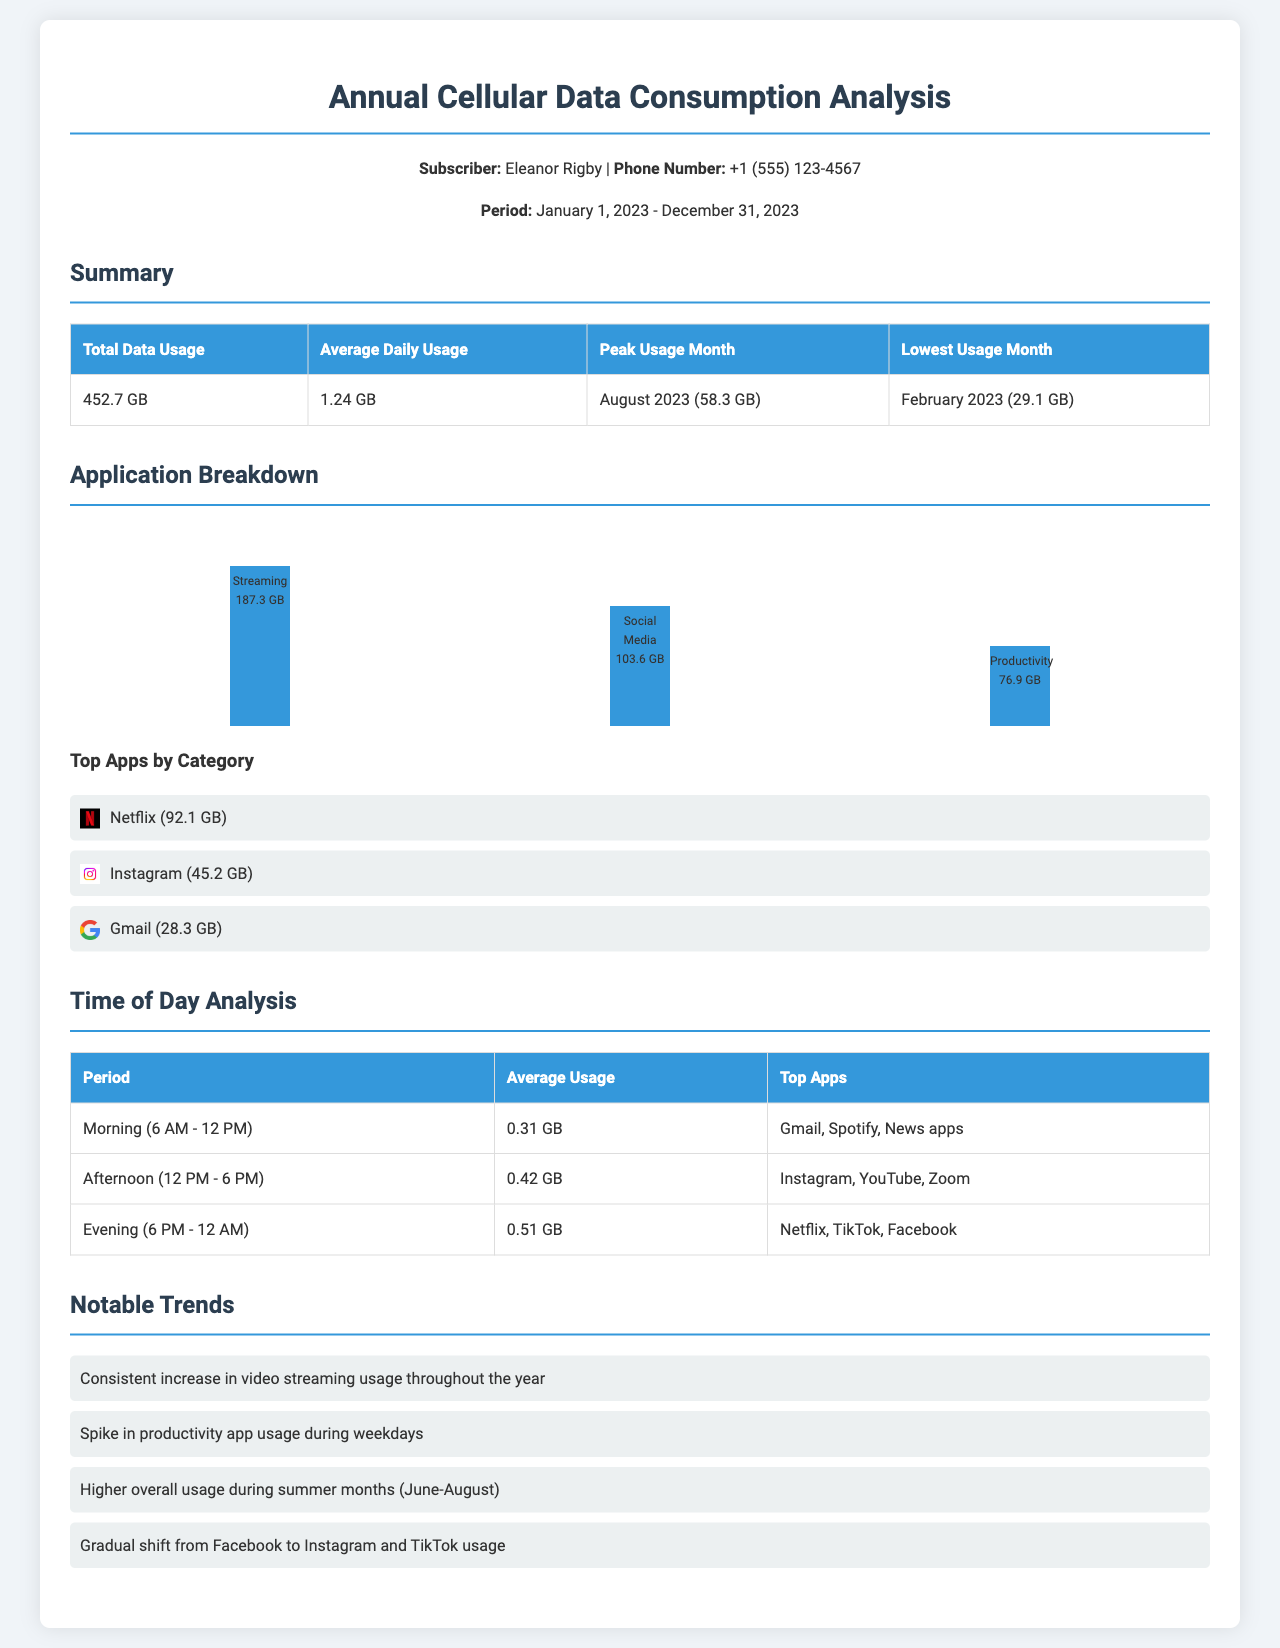What is the total data usage? The total data usage is listed in the summary section of the document as 452.7 GB.
Answer: 452.7 GB What was the peak usage month? The peak usage month is specified in the summary section as August 2023 (58.3 GB).
Answer: August 2023 (58.3 GB) Which application consumed the most data? The application that consumed the most data is found in the application breakdown as Streaming (187.3 GB).
Answer: Streaming (187.3 GB) What is the average daily usage? The average daily usage is detailed in the summary section and is 1.24 GB.
Answer: 1.24 GB Which period had the highest average usage? The period with the highest average usage can be inferred from the time analysis as Evening (6 PM - 12 AM) with 0.51 GB.
Answer: Evening (6 PM - 12 AM) What is the most used app in the morning? The most used app in the morning is mentioned in the time of day analysis as Gmail.
Answer: Gmail What month had the lowest data usage? The month with the lowest data usage is provided in the summary as February 2023 (29.1 GB).
Answer: February 2023 (29.1 GB) Which app had the second highest data consumption? The app with the second highest data consumption is identified in the application breakdown as Social Media (103.6 GB).
Answer: Social Media (103.6 GB) What notable trend was observed regarding video streaming? A notable trend mentioned is that there was a consistent increase in video streaming usage throughout the year.
Answer: Consistent increase in video streaming usage 